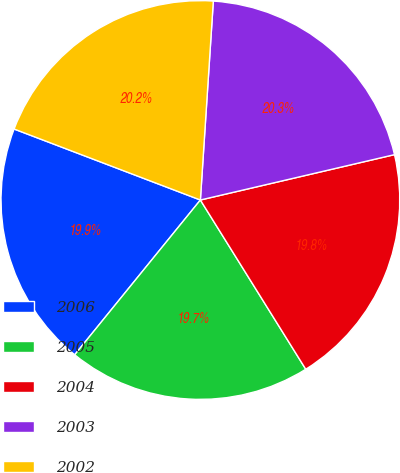Convert chart. <chart><loc_0><loc_0><loc_500><loc_500><pie_chart><fcel>2006<fcel>2005<fcel>2004<fcel>2003<fcel>2002<nl><fcel>19.94%<fcel>19.72%<fcel>19.79%<fcel>20.31%<fcel>20.24%<nl></chart> 